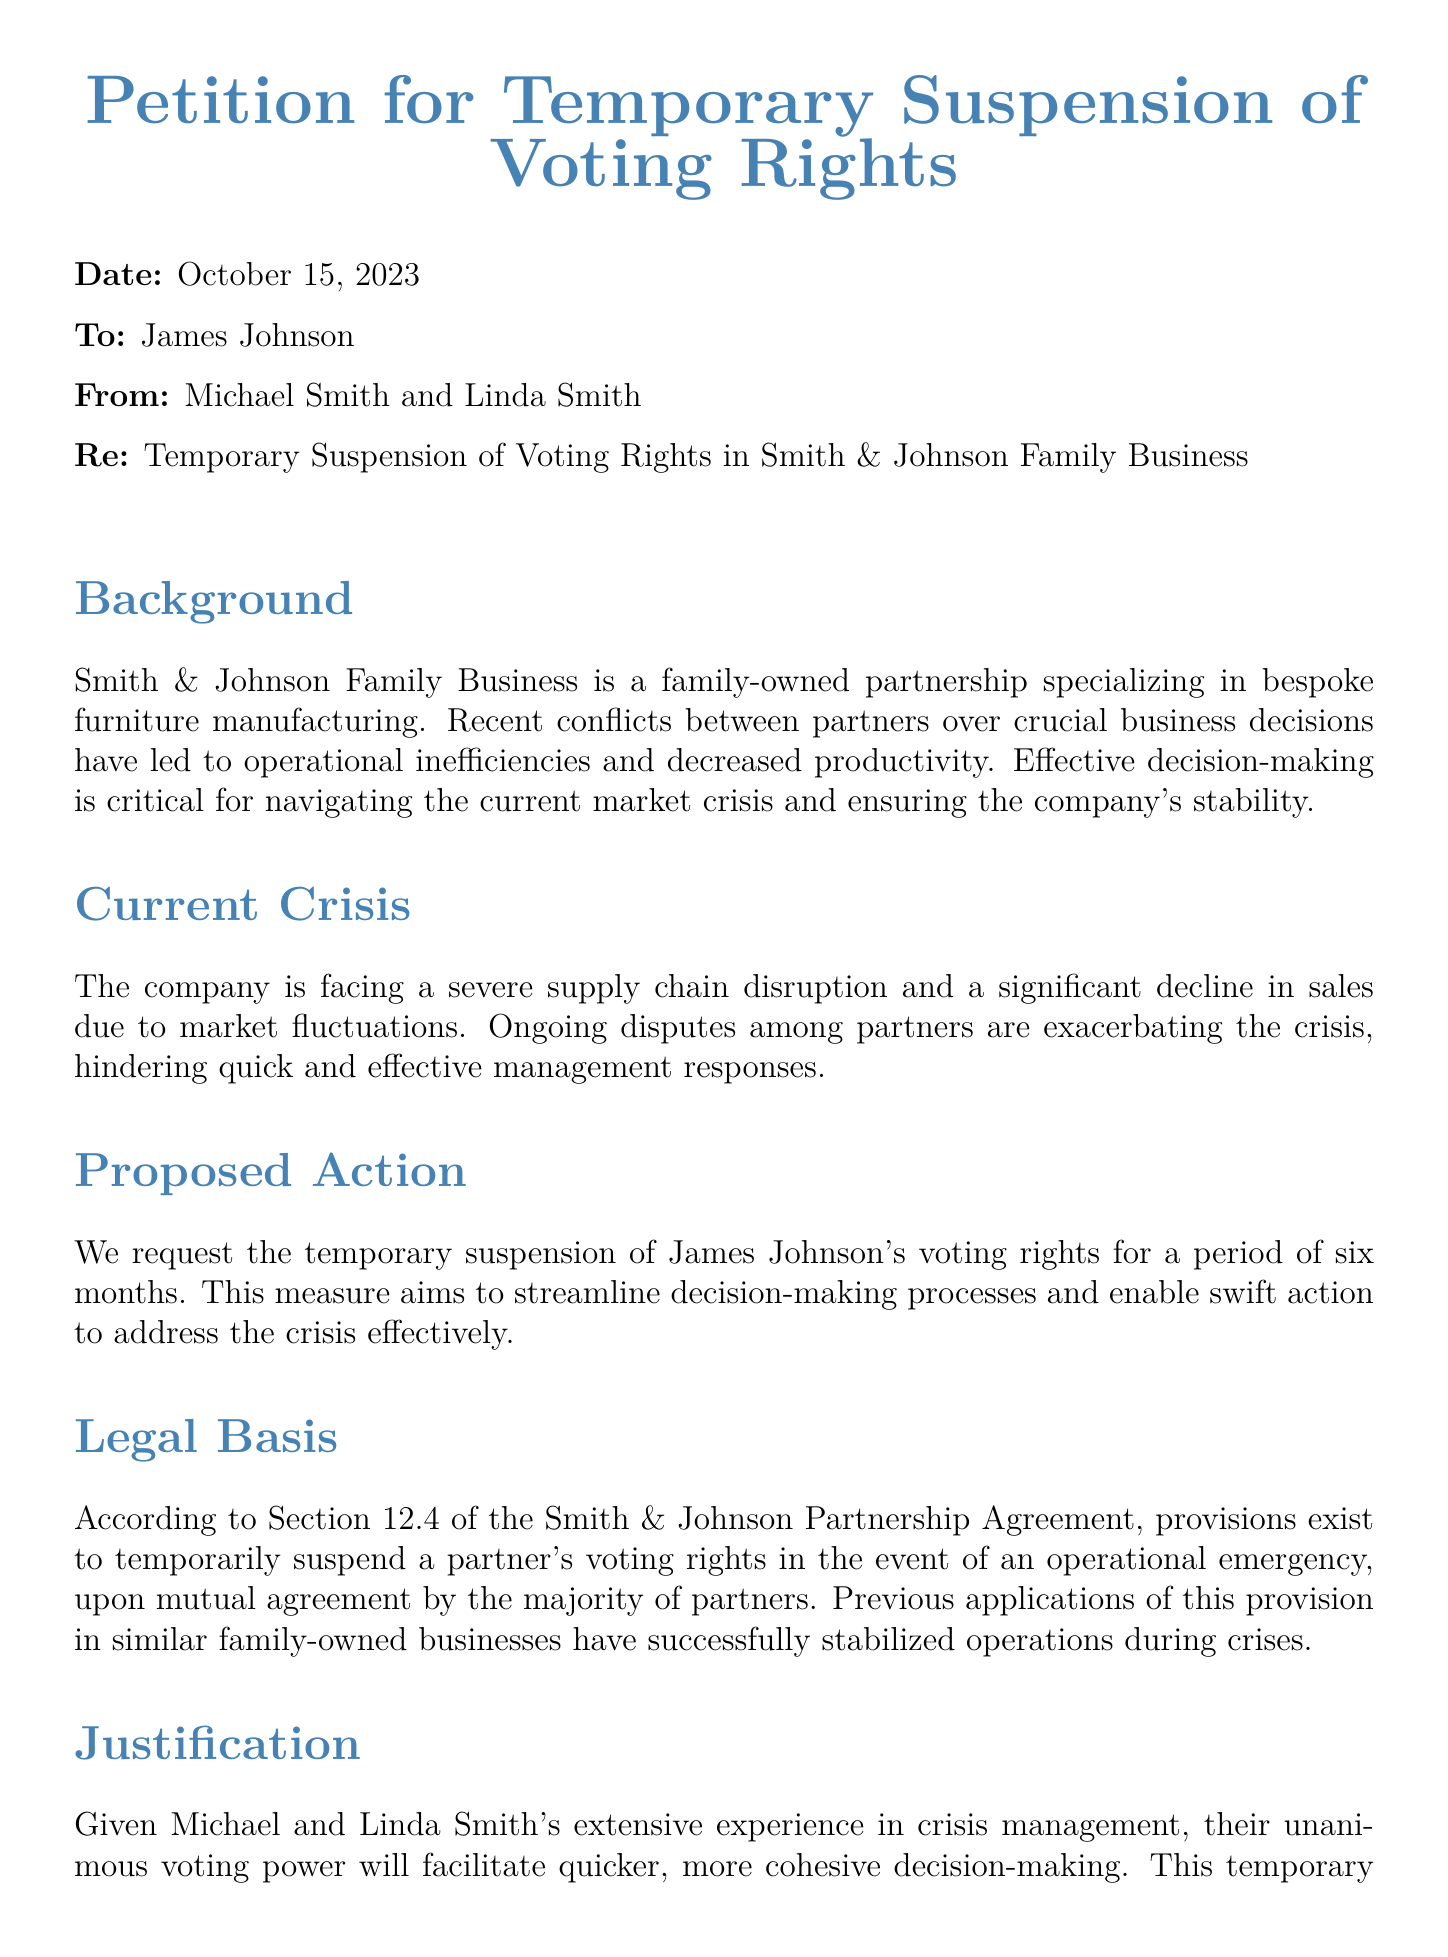what is the date of the petition? The date is explicitly mentioned at the beginning of the petition document as October 15, 2023.
Answer: October 15, 2023 who are the petitioners? The petitioners are identified as Michael Smith and Linda Smith in the "From" section of the document.
Answer: Michael Smith and Linda Smith what is the proposed action in the petition? The proposed action is outlined clearly under "Proposed Action" as requesting the temporary suspension of James Johnson's voting rights.
Answer: Temporary suspension of James Johnson's voting rights how long is the proposed suspension period? The duration of the proposed suspension period is specified as six months in the "Proposed Action" section.
Answer: six months what is cited as the legal basis for the petition? The legal basis is referenced in the "Legal Basis" section, where it mentions Section 12.4 of the Smith & Johnson Partnership Agreement.
Answer: Section 12.4 of the Smith & Johnson Partnership Agreement what is the primary reason for requesting the suspension of voting rights? The primary reason is discussed in the justification section, which emphasizes the need for streamlined decision-making to address the current market crisis.
Answer: streamline decision-making who is affected by the voting rights suspension? The individual affected by the voting rights suspension is explicitly stated as James Johnson in the proposed action section.
Answer: James Johnson how many partners are in the Smith & Johnson Family Business? The document implies there are at least three partners: Michael Smith, Linda Smith, and James Johnson, mentioned throughout the text.
Answer: three partners 